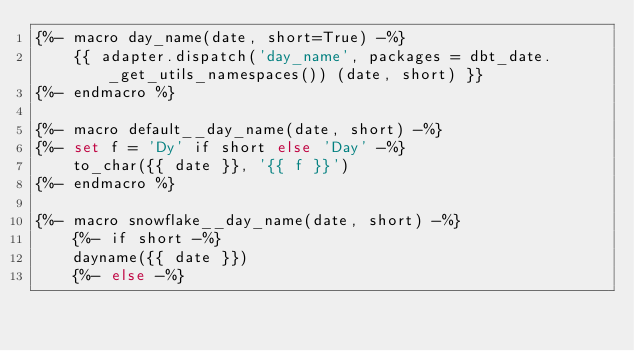Convert code to text. <code><loc_0><loc_0><loc_500><loc_500><_SQL_>{%- macro day_name(date, short=True) -%}
    {{ adapter.dispatch('day_name', packages = dbt_date._get_utils_namespaces()) (date, short) }}
{%- endmacro %}

{%- macro default__day_name(date, short) -%}
{%- set f = 'Dy' if short else 'Day' -%}
    to_char({{ date }}, '{{ f }}')
{%- endmacro %}

{%- macro snowflake__day_name(date, short) -%}
    {%- if short -%}
    dayname({{ date }})
    {%- else -%}</code> 